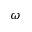Convert formula to latex. <formula><loc_0><loc_0><loc_500><loc_500>\omega</formula> 